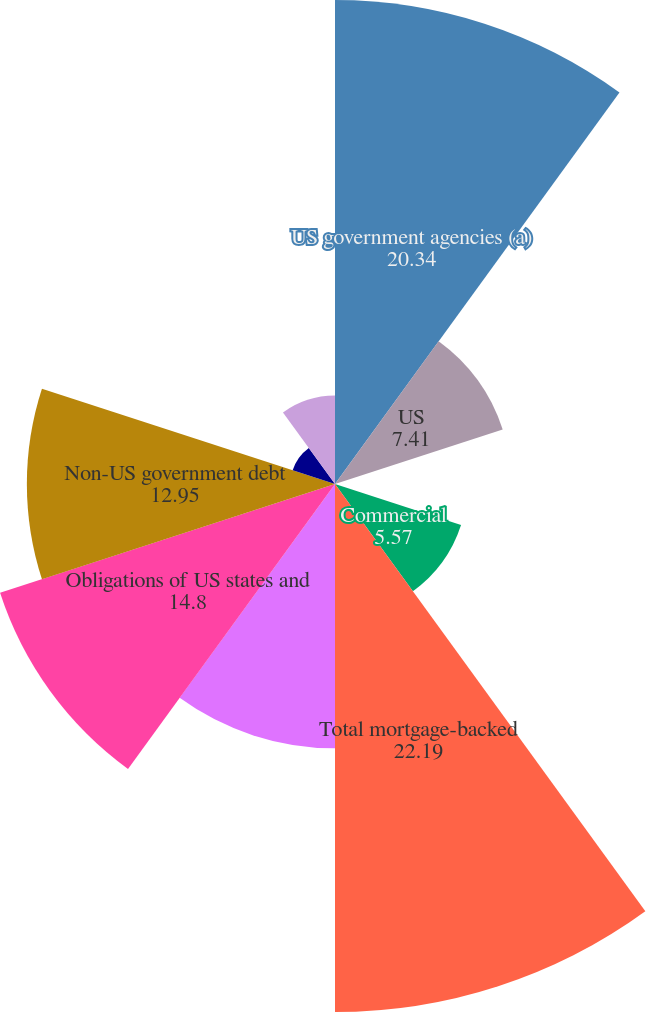Convert chart. <chart><loc_0><loc_0><loc_500><loc_500><pie_chart><fcel>US government agencies (a)<fcel>US<fcel>Non-US<fcel>Commercial<fcel>Total mortgage-backed<fcel>US Treasury and government<fcel>Obligations of US states and<fcel>Non-US government debt<fcel>Corporate debt securities<fcel>Collateralized loan<nl><fcel>20.34%<fcel>7.41%<fcel>0.03%<fcel>5.57%<fcel>22.19%<fcel>11.11%<fcel>14.8%<fcel>12.95%<fcel>1.87%<fcel>3.72%<nl></chart> 